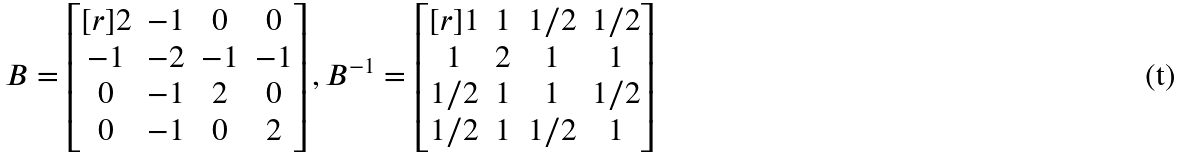<formula> <loc_0><loc_0><loc_500><loc_500>B = \begin{bmatrix} [ r ] 2 & - 1 & 0 & 0 \\ - 1 & - 2 & - 1 & - 1 \\ 0 & - 1 & 2 & 0 \\ 0 & - 1 & 0 & 2 \\ \end{bmatrix} , B ^ { - 1 } = \begin{bmatrix} [ r ] 1 & 1 & 1 / 2 & 1 / 2 \\ 1 & 2 & 1 & 1 \\ 1 / 2 & 1 & 1 & 1 / 2 \\ 1 / 2 & 1 & 1 / 2 & 1 \\ \end{bmatrix}</formula> 